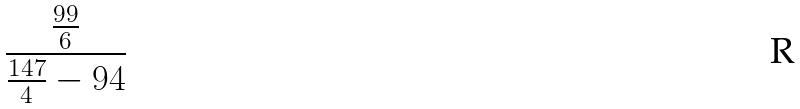<formula> <loc_0><loc_0><loc_500><loc_500>\frac { \frac { 9 9 } { 6 } } { \frac { 1 4 7 } { 4 } - 9 4 }</formula> 